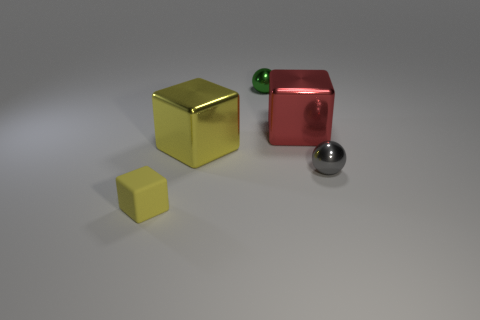What shape is the big shiny object that is the same color as the tiny cube?
Make the answer very short. Cube. What shape is the red thing that is the same material as the large yellow cube?
Keep it short and to the point. Cube. How many things are to the right of the big object behind the big shiny cube in front of the red metallic block?
Make the answer very short. 1. There is a small object that is both in front of the green thing and left of the red metal block; what is its shape?
Make the answer very short. Cube. Is the number of tiny gray spheres that are to the left of the rubber block less than the number of large blue things?
Your response must be concise. No. What number of big objects are either cyan rubber cylinders or yellow metal blocks?
Ensure brevity in your answer.  1. The yellow shiny block has what size?
Offer a terse response. Large. Is there any other thing that has the same material as the tiny yellow object?
Your response must be concise. No. What number of yellow cubes are on the left side of the large yellow cube?
Your answer should be very brief. 1. The yellow metallic object that is the same shape as the big red object is what size?
Keep it short and to the point. Large. 